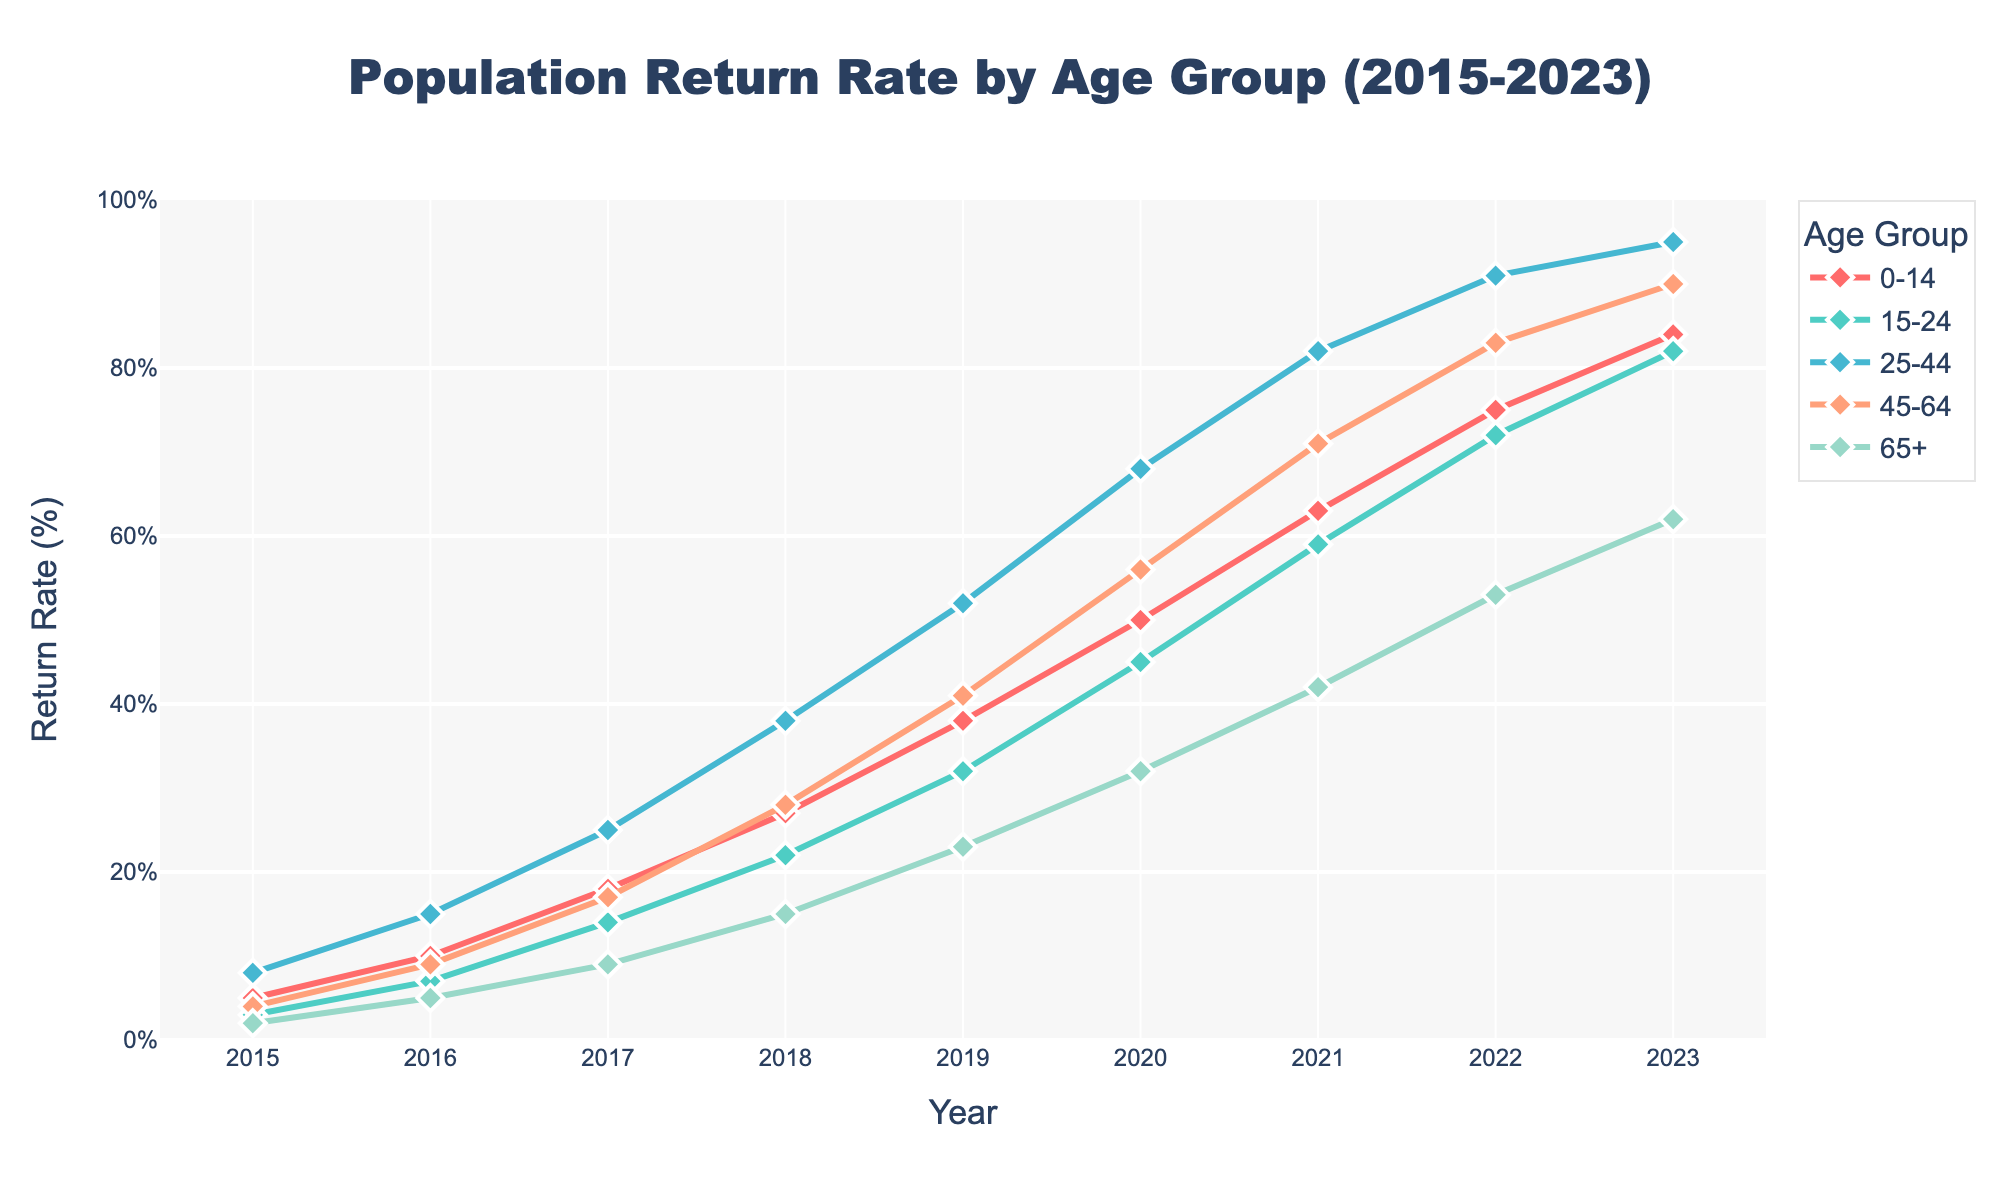What's the highest return rate among all age groups in 2023? To find the highest return rate, we look at the 2023 values for all age groups: 84 (0-14), 82 (15-24), 95 (25-44), 90 (45-64), and 62 (65+). The highest value is 95, which belongs to the 25-44 age group.
Answer: 95 Which age group had the lowest return rate in 2015? For the year 2015, the return rates are: 5 (0-14), 3 (15-24), 8 (25-44), 4 (45-64), and 2 (65+). The lowest value is 2, which belongs to the 65+ age group.
Answer: 65+ How much did the return rate for the 45-64 age group increase between 2016 and 2022? The return rate for the 45-64 age group in 2016 is 9, and in 2022, it is 83. The increase is calculated as 83 - 9, which equals 74.
Answer: 74 In which year did the 0-14 age group surpass a return rate of 50%? We need to find the first year where the 0-14 age group had a return rate above 50. The values are: 2015 (5), 2016 (10), 2017 (18), 2018 (27), 2019 (38), 2020 (50), 2021 (63). The year is 2021.
Answer: 2021 By how much did the return rate of the 15-24 age group change from 2019 to 2020? The return rate for the 15-24 age group in 2019 is 32, and in 2020, it is 45. The change is calculated as 45 - 32, which equals 13.
Answer: 13 What is the average return rate of the 25-44 age group over the entire period from 2015 to 2023? The values for the 25-44 age group from 2015 to 2023 are: 8, 15, 25, 38, 52, 68, 82, 91, 95. The sum is 474, and there are 9 years. The average is 474 / 9 = 52.67.
Answer: 52.67 Did any age group have a return rate above 80% before 2021? We need to check the return rates of all age groups for the years before 2021. No age group had a return rate above 80% in these years.
Answer: No Which age group had the largest rate of increase from 2015 to 2023? The increase from 2015 to 2023 for each age group is calculated: 0-14: 84-5=79, 15-24: 82-3=79, 25-44: 95-8=87, 45-64: 90-4=86, 65+: 62-2=60. The largest increase is 87 for the 25-44 age group.
Answer: 25-44 Between 2016 and 2017, which age group saw the highest proportional increase in return rate? To find the proportional increase: 0-14: (18-10)/10=0.8, 15-24: (14-7)/7=1.0, 25-44: (25-15)/15=0.67, 45-64: (17-9)/9=0.89, 65+: (9-5)/5=0.8. The highest proportional increase is for the 15-24 age group at 1.0 (100%).
Answer: 15-24 